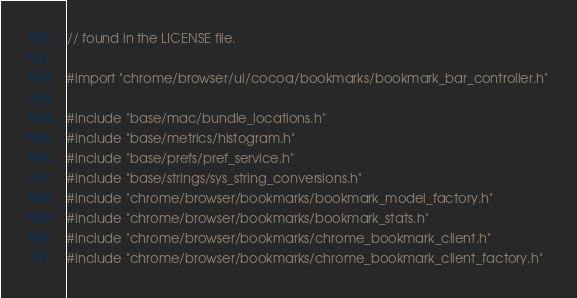Convert code to text. <code><loc_0><loc_0><loc_500><loc_500><_ObjectiveC_>// found in the LICENSE file.

#import "chrome/browser/ui/cocoa/bookmarks/bookmark_bar_controller.h"

#include "base/mac/bundle_locations.h"
#include "base/metrics/histogram.h"
#include "base/prefs/pref_service.h"
#include "base/strings/sys_string_conversions.h"
#include "chrome/browser/bookmarks/bookmark_model_factory.h"
#include "chrome/browser/bookmarks/bookmark_stats.h"
#include "chrome/browser/bookmarks/chrome_bookmark_client.h"
#include "chrome/browser/bookmarks/chrome_bookmark_client_factory.h"</code> 